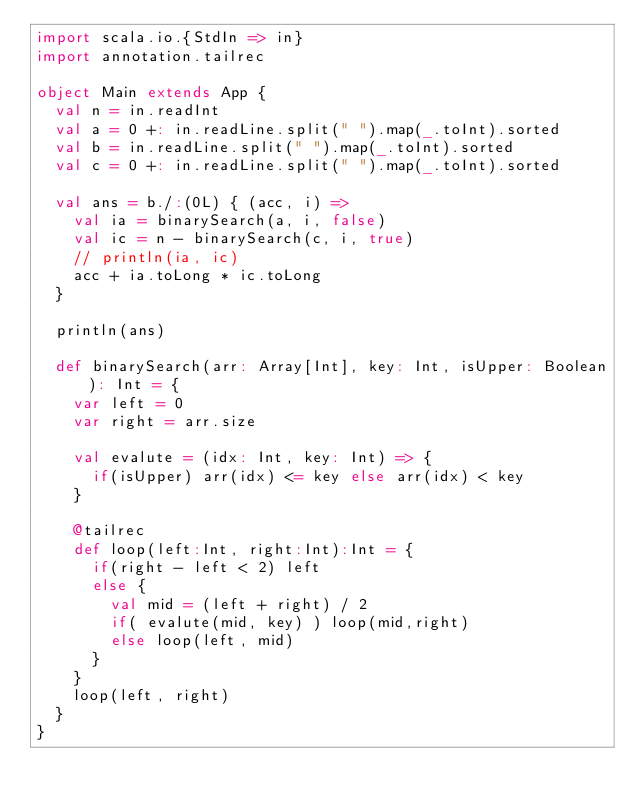Convert code to text. <code><loc_0><loc_0><loc_500><loc_500><_Scala_>import scala.io.{StdIn => in}
import annotation.tailrec

object Main extends App {
  val n = in.readInt
  val a = 0 +: in.readLine.split(" ").map(_.toInt).sorted
  val b = in.readLine.split(" ").map(_.toInt).sorted
  val c = 0 +: in.readLine.split(" ").map(_.toInt).sorted

  val ans = b./:(0L) { (acc, i) =>
    val ia = binarySearch(a, i, false)
    val ic = n - binarySearch(c, i, true)
    // println(ia, ic)
    acc + ia.toLong * ic.toLong
  }
  
  println(ans)

  def binarySearch(arr: Array[Int], key: Int, isUpper: Boolean): Int = {
    var left = 0
    var right = arr.size

    val evalute = (idx: Int, key: Int) => {
      if(isUpper) arr(idx) <= key else arr(idx) < key
    }

    @tailrec
    def loop(left:Int, right:Int):Int = {
      if(right - left < 2) left
      else {
        val mid = (left + right) / 2
        if( evalute(mid, key) ) loop(mid,right)
        else loop(left, mid)
      }
    }
    loop(left, right)
  }
}</code> 